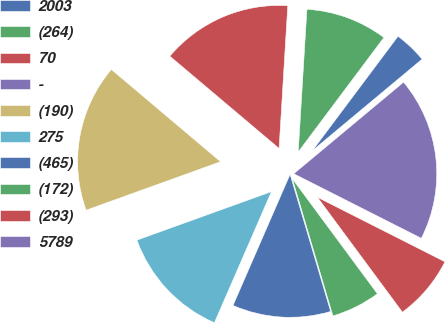Convert chart to OTSL. <chart><loc_0><loc_0><loc_500><loc_500><pie_chart><fcel>2003<fcel>(264)<fcel>70<fcel>-<fcel>(190)<fcel>275<fcel>(465)<fcel>(172)<fcel>(293)<fcel>5789<nl><fcel>3.71%<fcel>9.26%<fcel>14.81%<fcel>0.0%<fcel>16.67%<fcel>12.96%<fcel>11.11%<fcel>5.56%<fcel>7.41%<fcel>18.52%<nl></chart> 